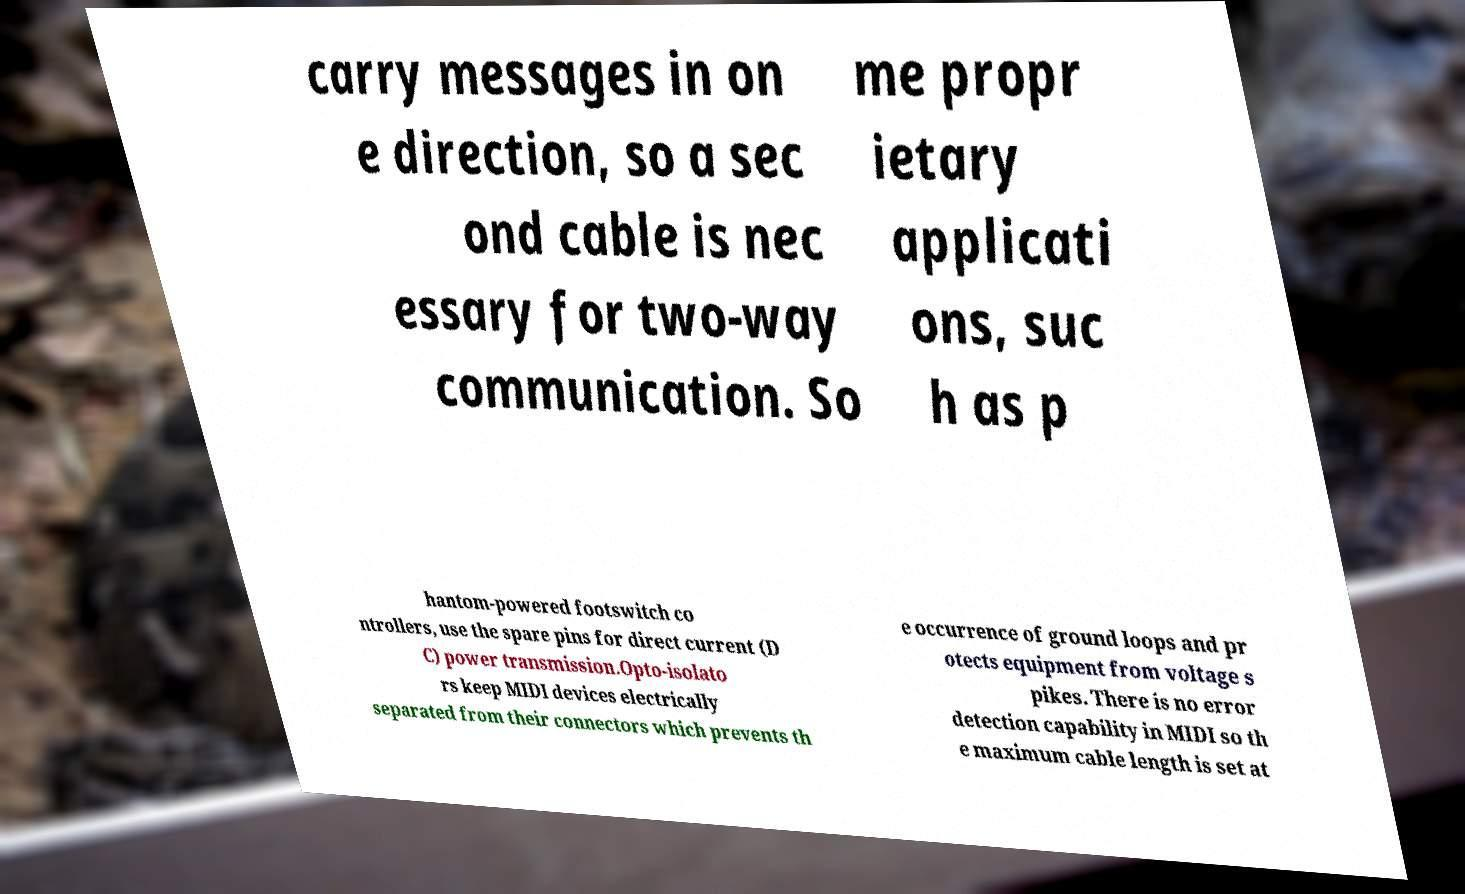For documentation purposes, I need the text within this image transcribed. Could you provide that? carry messages in on e direction, so a sec ond cable is nec essary for two-way communication. So me propr ietary applicati ons, suc h as p hantom-powered footswitch co ntrollers, use the spare pins for direct current (D C) power transmission.Opto-isolato rs keep MIDI devices electrically separated from their connectors which prevents th e occurrence of ground loops and pr otects equipment from voltage s pikes. There is no error detection capability in MIDI so th e maximum cable length is set at 